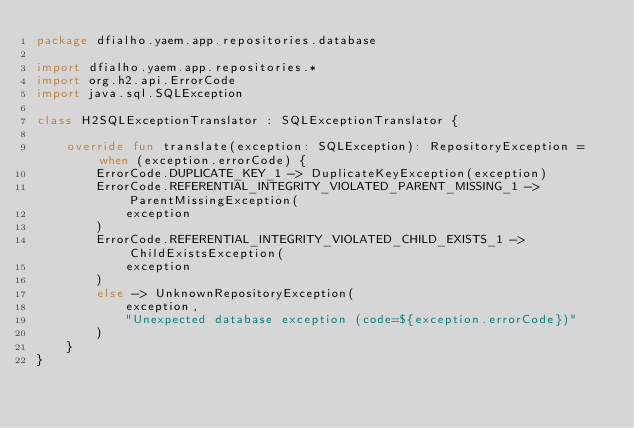<code> <loc_0><loc_0><loc_500><loc_500><_Kotlin_>package dfialho.yaem.app.repositories.database

import dfialho.yaem.app.repositories.*
import org.h2.api.ErrorCode
import java.sql.SQLException

class H2SQLExceptionTranslator : SQLExceptionTranslator {

    override fun translate(exception: SQLException): RepositoryException = when (exception.errorCode) {
        ErrorCode.DUPLICATE_KEY_1 -> DuplicateKeyException(exception)
        ErrorCode.REFERENTIAL_INTEGRITY_VIOLATED_PARENT_MISSING_1 -> ParentMissingException(
            exception
        )
        ErrorCode.REFERENTIAL_INTEGRITY_VIOLATED_CHILD_EXISTS_1 -> ChildExistsException(
            exception
        )
        else -> UnknownRepositoryException(
            exception,
            "Unexpected database exception (code=${exception.errorCode})"
        )
    }
}</code> 